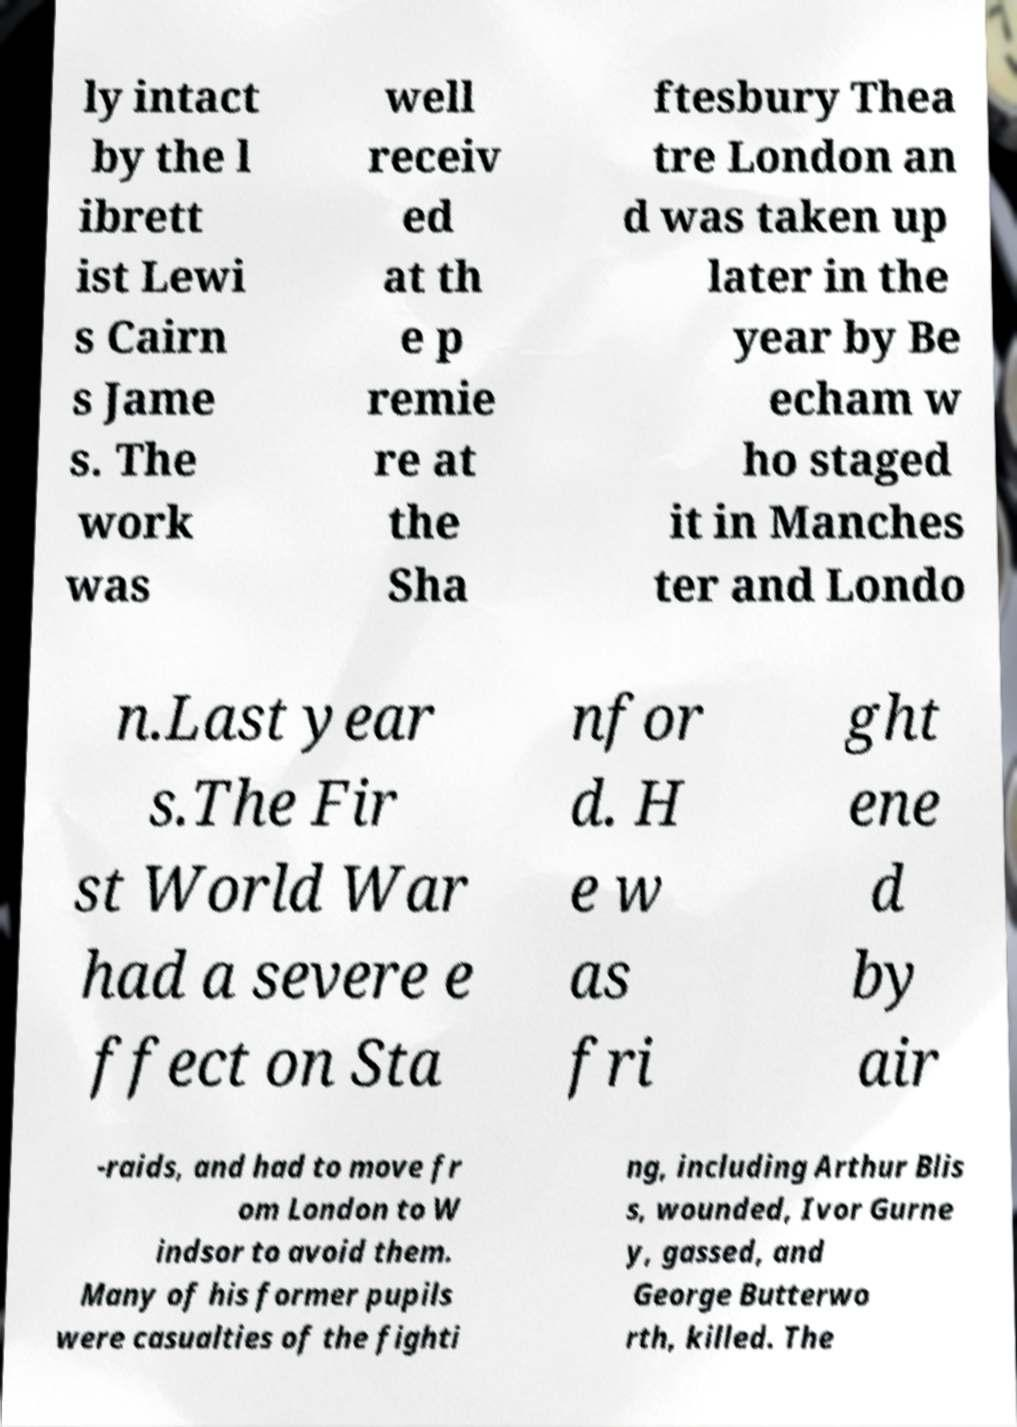Please identify and transcribe the text found in this image. ly intact by the l ibrett ist Lewi s Cairn s Jame s. The work was well receiv ed at th e p remie re at the Sha ftesbury Thea tre London an d was taken up later in the year by Be echam w ho staged it in Manches ter and Londo n.Last year s.The Fir st World War had a severe e ffect on Sta nfor d. H e w as fri ght ene d by air -raids, and had to move fr om London to W indsor to avoid them. Many of his former pupils were casualties of the fighti ng, including Arthur Blis s, wounded, Ivor Gurne y, gassed, and George Butterwo rth, killed. The 